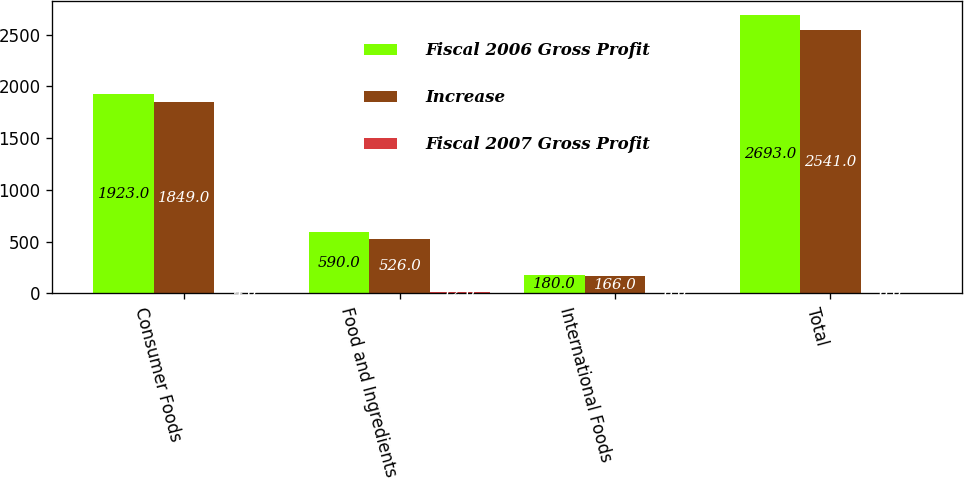Convert chart to OTSL. <chart><loc_0><loc_0><loc_500><loc_500><stacked_bar_chart><ecel><fcel>Consumer Foods<fcel>Food and Ingredients<fcel>International Foods<fcel>Total<nl><fcel>Fiscal 2006 Gross Profit<fcel>1923<fcel>590<fcel>180<fcel>2693<nl><fcel>Increase<fcel>1849<fcel>526<fcel>166<fcel>2541<nl><fcel>Fiscal 2007 Gross Profit<fcel>4<fcel>12<fcel>8<fcel>6<nl></chart> 